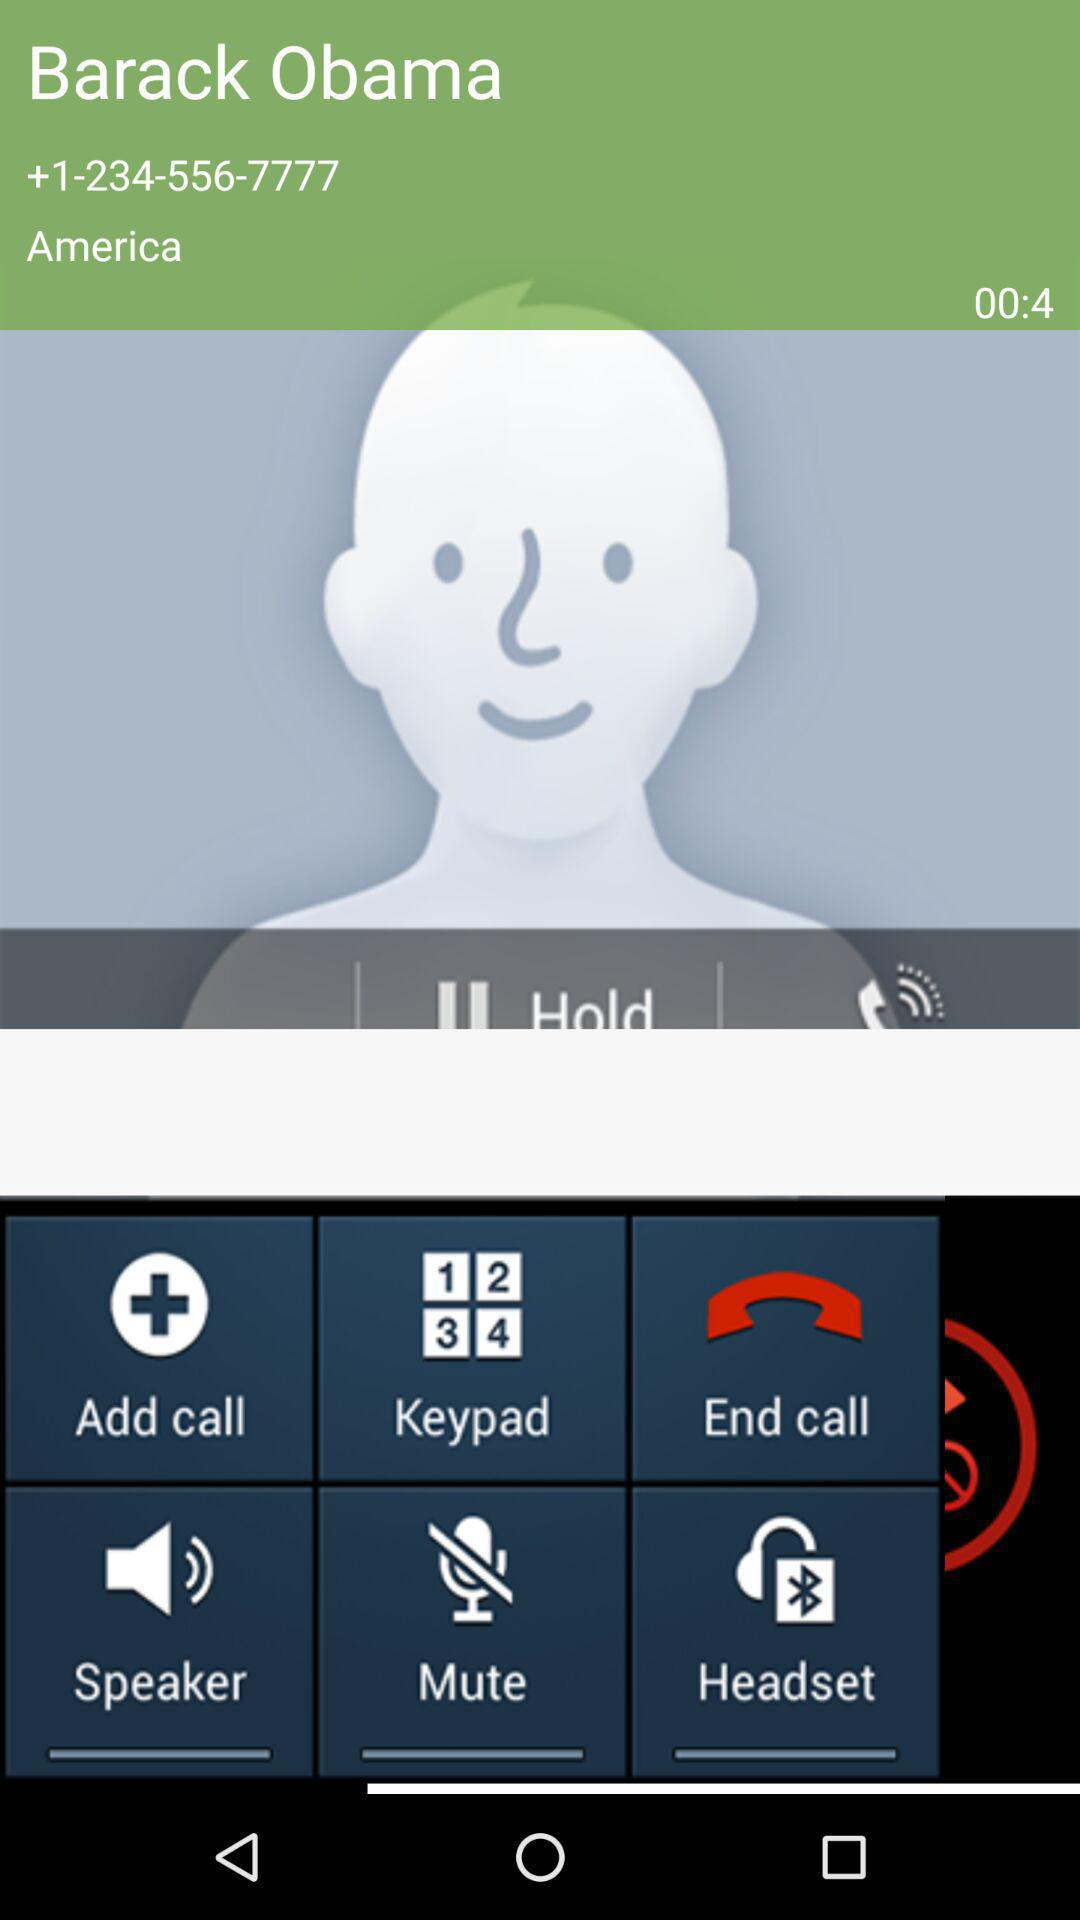What country is given? The given country is America. 